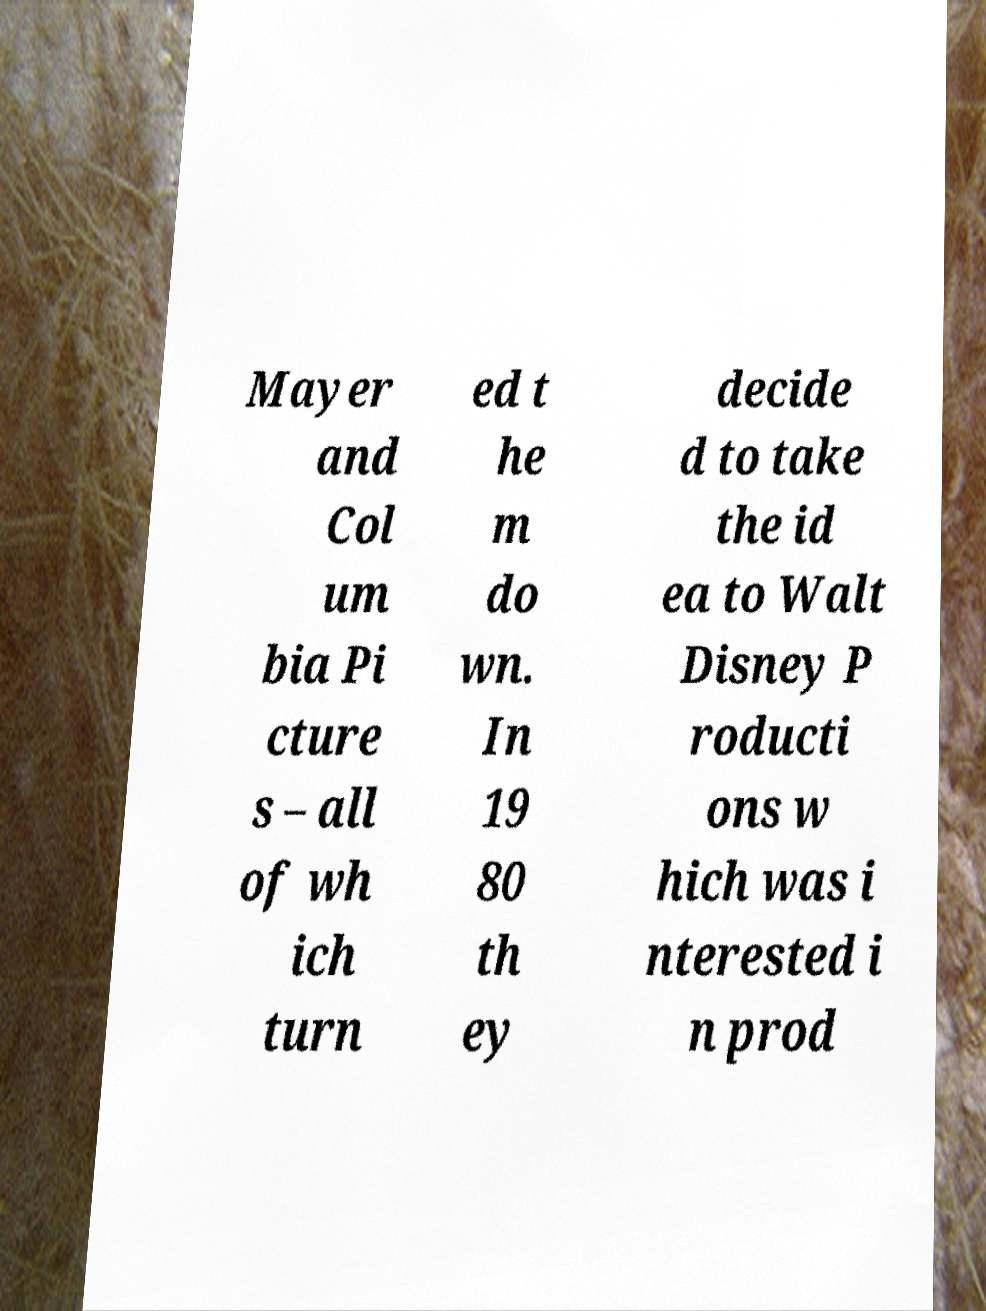Can you accurately transcribe the text from the provided image for me? Mayer and Col um bia Pi cture s – all of wh ich turn ed t he m do wn. In 19 80 th ey decide d to take the id ea to Walt Disney P roducti ons w hich was i nterested i n prod 